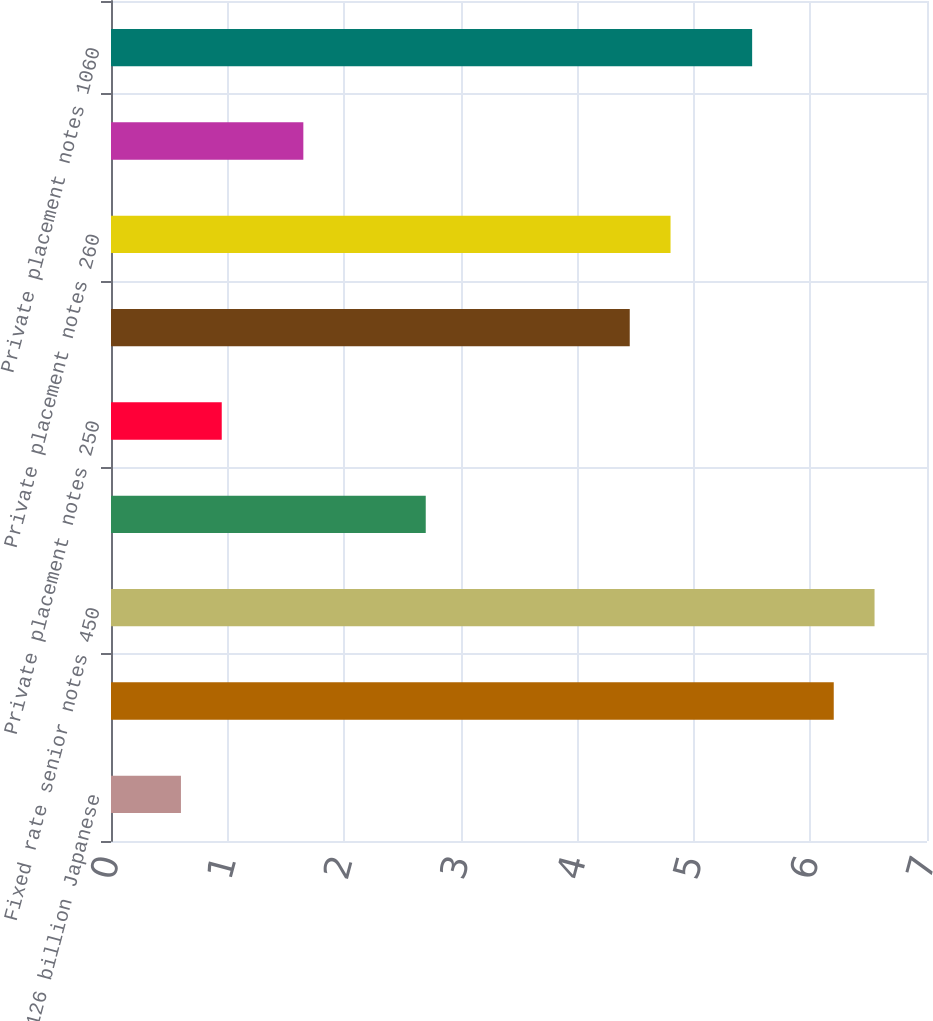Convert chart to OTSL. <chart><loc_0><loc_0><loc_500><loc_500><bar_chart><fcel>Term loan 126 billion Japanese<fcel>Term loan 1750 million due<fcel>Fixed rate senior notes 450<fcel>Private placement notes 700<fcel>Private placement notes 250<fcel>Private placement notes 970<fcel>Private placement notes 260<fcel>Private placement notes 580<fcel>Private placement notes 1060<nl><fcel>0.6<fcel>6.2<fcel>6.55<fcel>2.7<fcel>0.95<fcel>4.45<fcel>4.8<fcel>1.65<fcel>5.5<nl></chart> 